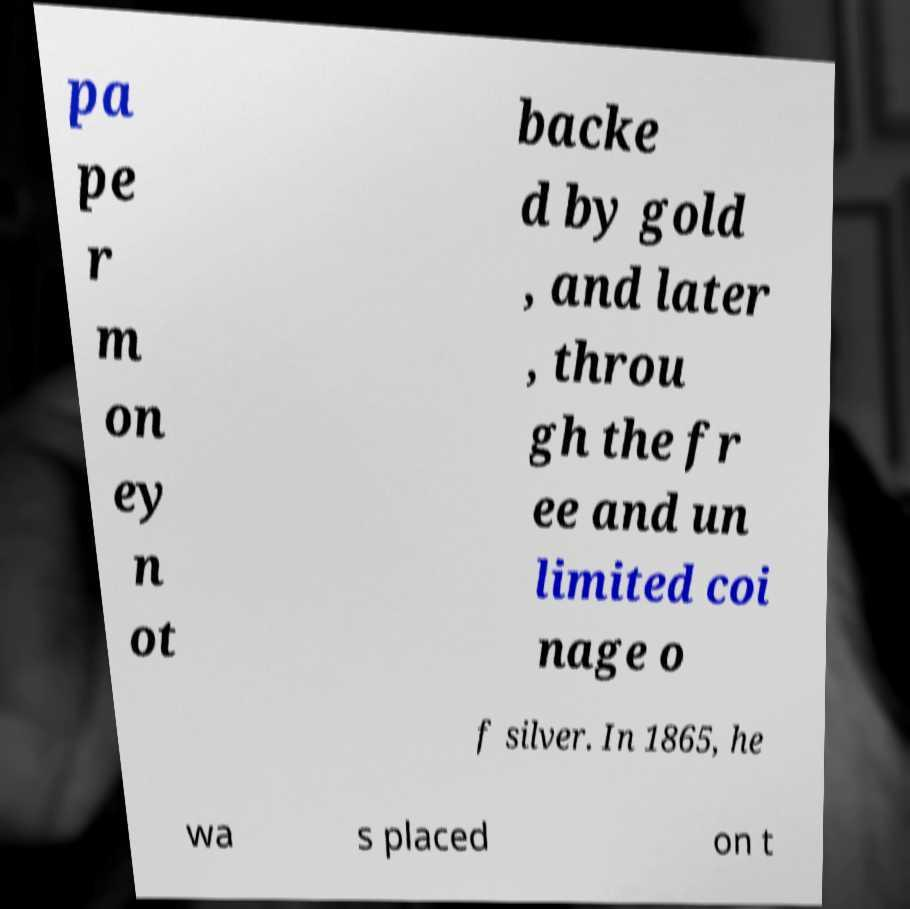Could you extract and type out the text from this image? pa pe r m on ey n ot backe d by gold , and later , throu gh the fr ee and un limited coi nage o f silver. In 1865, he wa s placed on t 